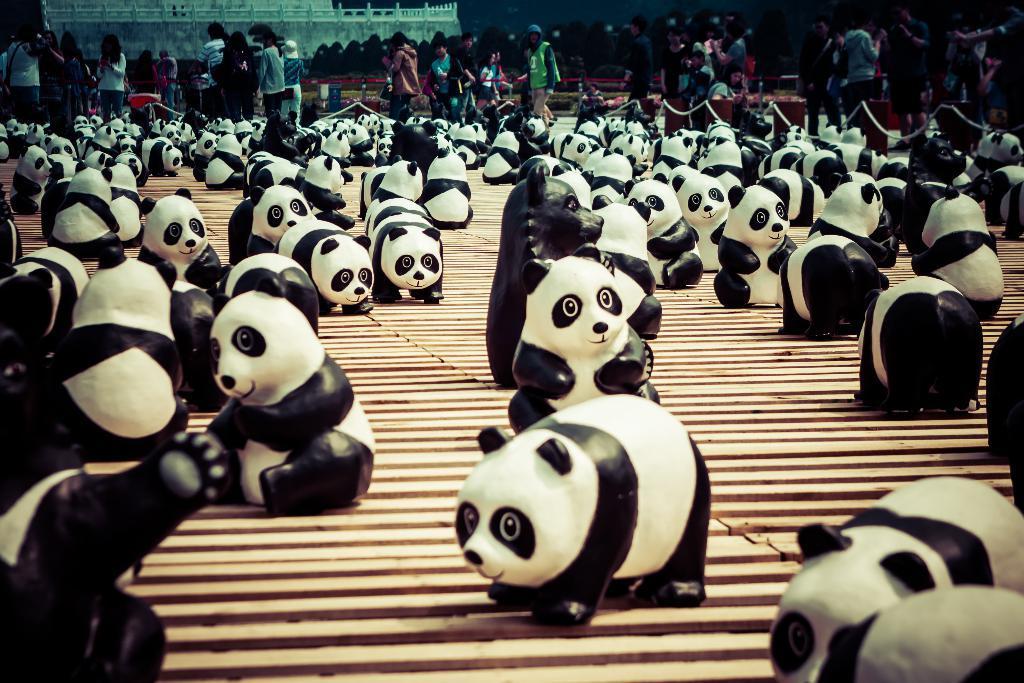Can you describe this image briefly? In the center of the image there are depictions of pandas. In the background of the image there are people walking. 